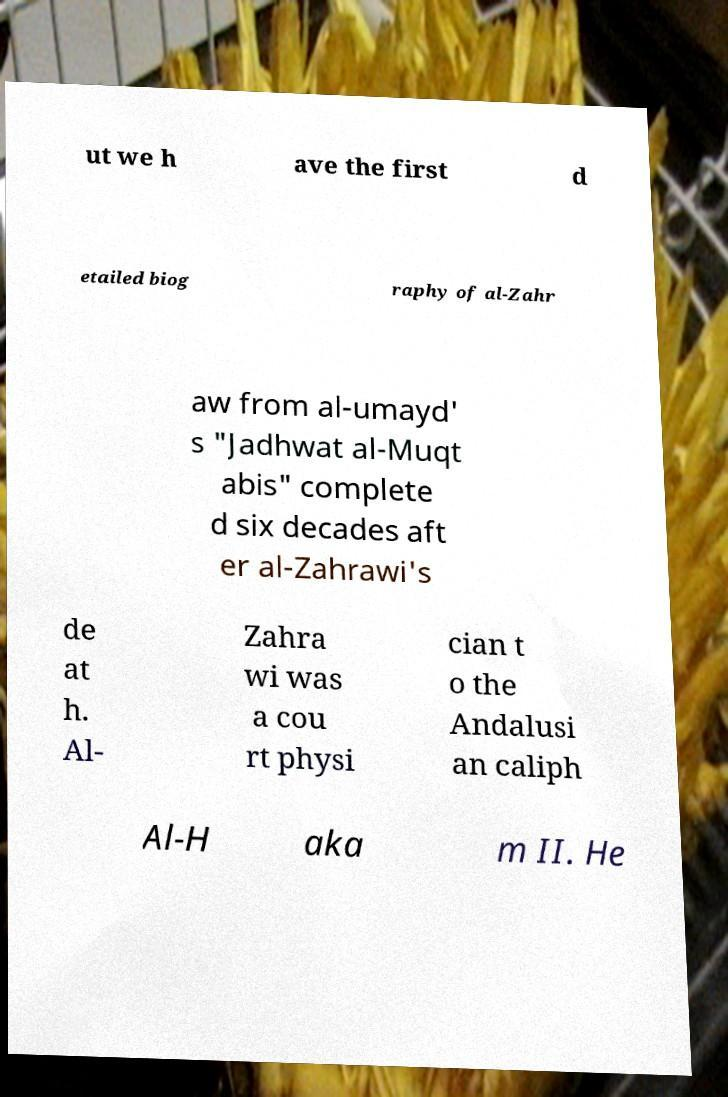There's text embedded in this image that I need extracted. Can you transcribe it verbatim? ut we h ave the first d etailed biog raphy of al-Zahr aw from al-umayd' s "Jadhwat al-Muqt abis" complete d six decades aft er al-Zahrawi's de at h. Al- Zahra wi was a cou rt physi cian t o the Andalusi an caliph Al-H aka m II. He 